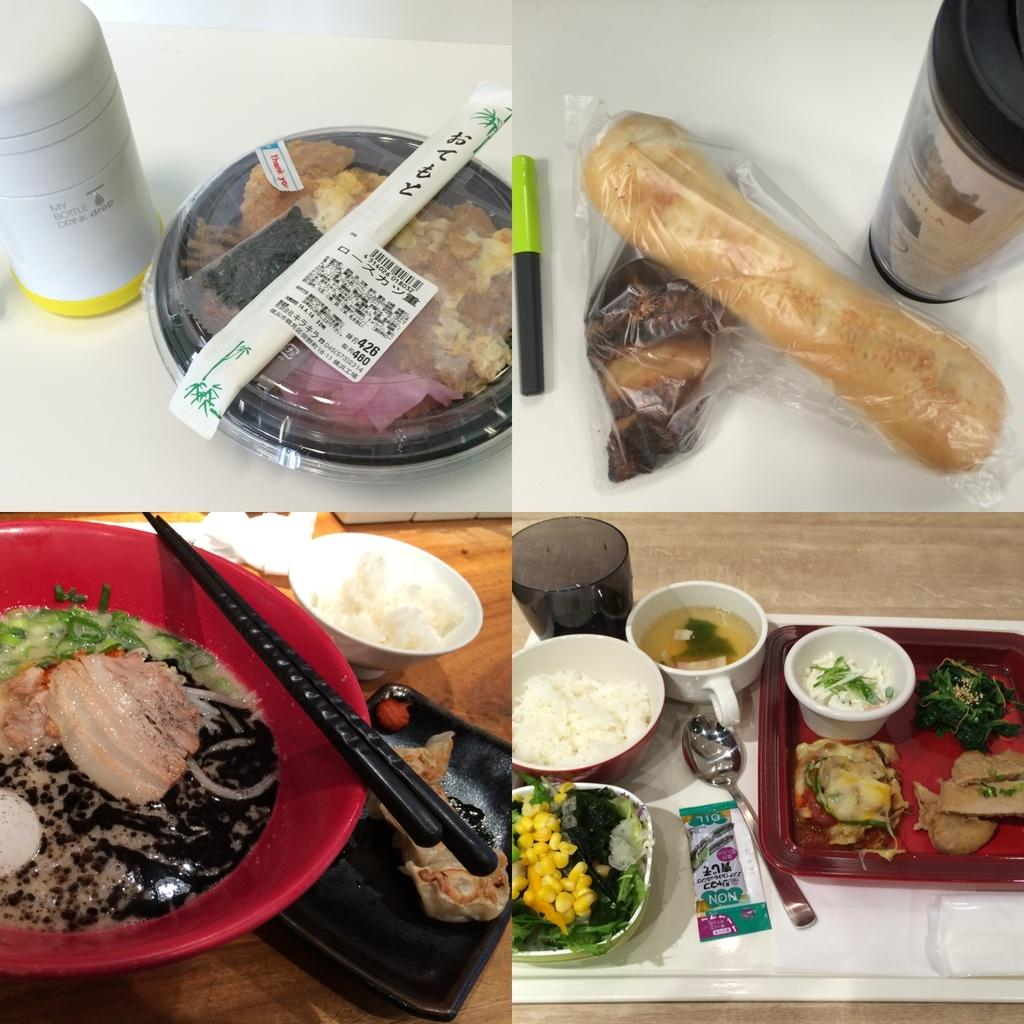What type of utensil is visible in the image? There is a spoon in the image. What type of containers are present in the image? There are cups, a glass, and bottles in the image. What type of utensil is typically used for eating Asian cuisine? Chopsticks are present in the image, which are commonly used for eating Asian cuisine. What can be found on the table in the image? There is a variety of food items on the table in the image. What type of fruit is hanging from the cap on the boat in the image? There is no cap or boat present in the image; it features a variety of food items, cups, a glass, bottles, and utensils on a table. What type of boat is used to transport the pear in the image? There is no pear, cap, or boat present in the image. 